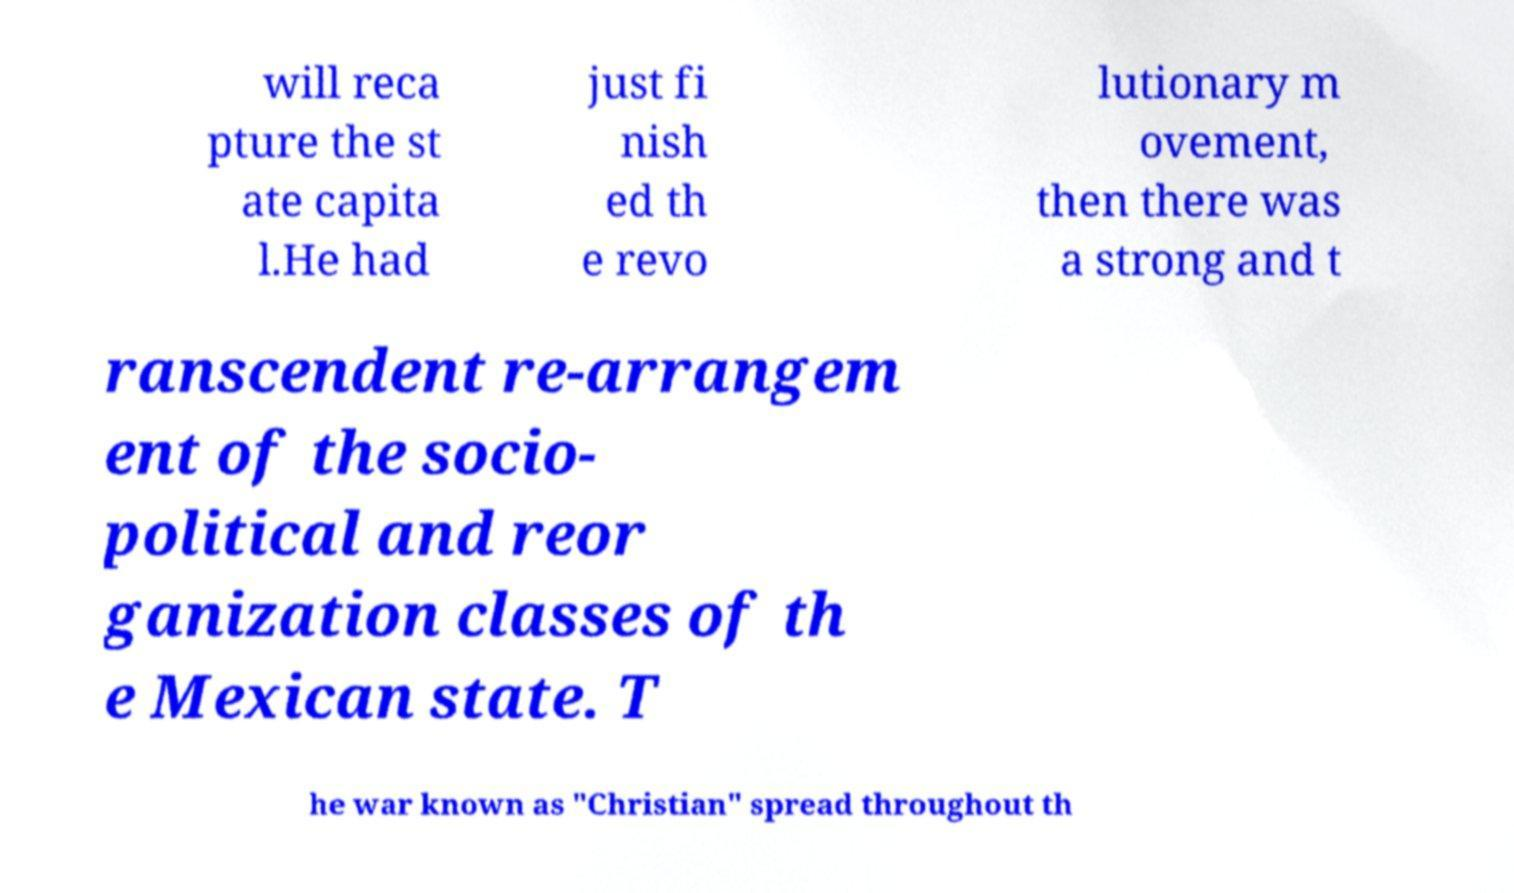Could you extract and type out the text from this image? will reca pture the st ate capita l.He had just fi nish ed th e revo lutionary m ovement, then there was a strong and t ranscendent re-arrangem ent of the socio- political and reor ganization classes of th e Mexican state. T he war known as "Christian" spread throughout th 